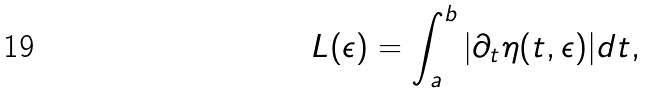<formula> <loc_0><loc_0><loc_500><loc_500>L ( \epsilon ) = \int _ { a } ^ { b } | \partial _ { t } \eta ( t , \epsilon ) | d t ,</formula> 